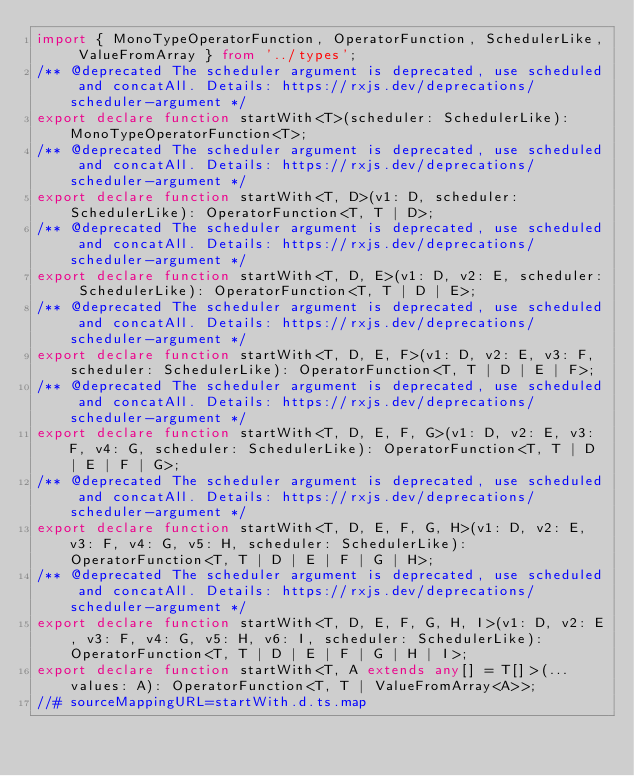<code> <loc_0><loc_0><loc_500><loc_500><_TypeScript_>import { MonoTypeOperatorFunction, OperatorFunction, SchedulerLike, ValueFromArray } from '../types';
/** @deprecated The scheduler argument is deprecated, use scheduled and concatAll. Details: https://rxjs.dev/deprecations/scheduler-argument */
export declare function startWith<T>(scheduler: SchedulerLike): MonoTypeOperatorFunction<T>;
/** @deprecated The scheduler argument is deprecated, use scheduled and concatAll. Details: https://rxjs.dev/deprecations/scheduler-argument */
export declare function startWith<T, D>(v1: D, scheduler: SchedulerLike): OperatorFunction<T, T | D>;
/** @deprecated The scheduler argument is deprecated, use scheduled and concatAll. Details: https://rxjs.dev/deprecations/scheduler-argument */
export declare function startWith<T, D, E>(v1: D, v2: E, scheduler: SchedulerLike): OperatorFunction<T, T | D | E>;
/** @deprecated The scheduler argument is deprecated, use scheduled and concatAll. Details: https://rxjs.dev/deprecations/scheduler-argument */
export declare function startWith<T, D, E, F>(v1: D, v2: E, v3: F, scheduler: SchedulerLike): OperatorFunction<T, T | D | E | F>;
/** @deprecated The scheduler argument is deprecated, use scheduled and concatAll. Details: https://rxjs.dev/deprecations/scheduler-argument */
export declare function startWith<T, D, E, F, G>(v1: D, v2: E, v3: F, v4: G, scheduler: SchedulerLike): OperatorFunction<T, T | D | E | F | G>;
/** @deprecated The scheduler argument is deprecated, use scheduled and concatAll. Details: https://rxjs.dev/deprecations/scheduler-argument */
export declare function startWith<T, D, E, F, G, H>(v1: D, v2: E, v3: F, v4: G, v5: H, scheduler: SchedulerLike): OperatorFunction<T, T | D | E | F | G | H>;
/** @deprecated The scheduler argument is deprecated, use scheduled and concatAll. Details: https://rxjs.dev/deprecations/scheduler-argument */
export declare function startWith<T, D, E, F, G, H, I>(v1: D, v2: E, v3: F, v4: G, v5: H, v6: I, scheduler: SchedulerLike): OperatorFunction<T, T | D | E | F | G | H | I>;
export declare function startWith<T, A extends any[] = T[]>(...values: A): OperatorFunction<T, T | ValueFromArray<A>>;
//# sourceMappingURL=startWith.d.ts.map</code> 